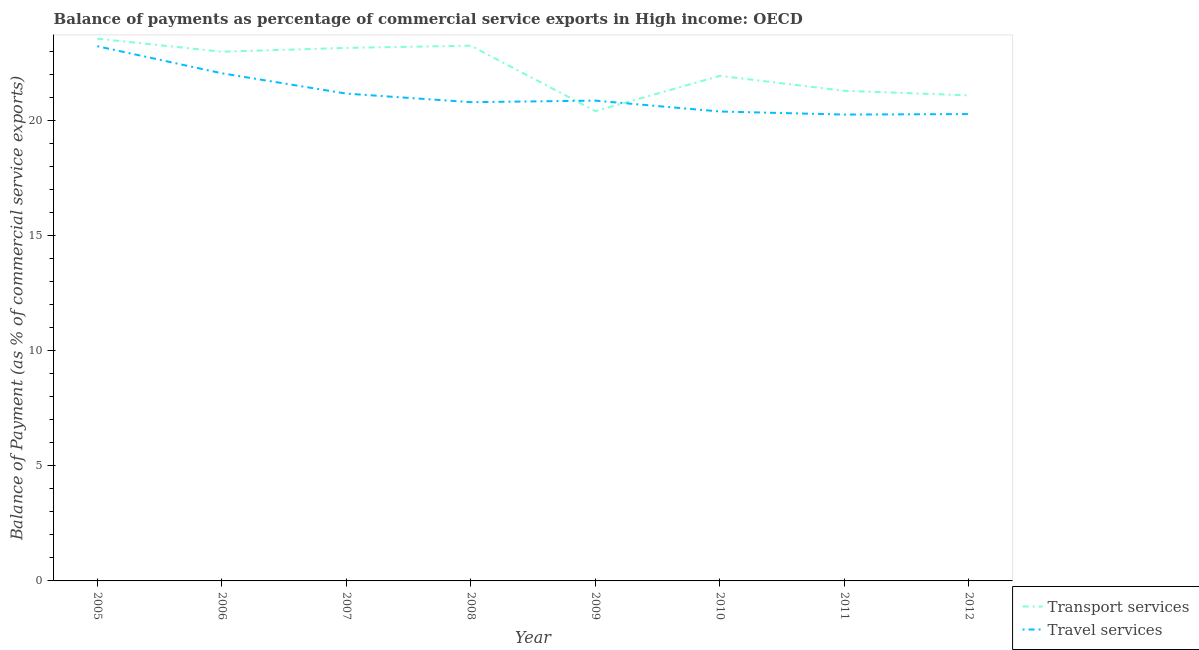How many different coloured lines are there?
Your answer should be very brief. 2. Does the line corresponding to balance of payments of travel services intersect with the line corresponding to balance of payments of transport services?
Give a very brief answer. Yes. What is the balance of payments of transport services in 2009?
Offer a very short reply. 20.43. Across all years, what is the maximum balance of payments of transport services?
Provide a succinct answer. 23.58. Across all years, what is the minimum balance of payments of transport services?
Offer a very short reply. 20.43. In which year was the balance of payments of transport services minimum?
Keep it short and to the point. 2009. What is the total balance of payments of travel services in the graph?
Your answer should be very brief. 169.21. What is the difference between the balance of payments of travel services in 2007 and that in 2012?
Keep it short and to the point. 0.89. What is the difference between the balance of payments of travel services in 2008 and the balance of payments of transport services in 2005?
Give a very brief answer. -2.76. What is the average balance of payments of transport services per year?
Your answer should be very brief. 22.23. In the year 2008, what is the difference between the balance of payments of transport services and balance of payments of travel services?
Offer a very short reply. 2.46. What is the ratio of the balance of payments of travel services in 2006 to that in 2011?
Offer a very short reply. 1.09. What is the difference between the highest and the second highest balance of payments of travel services?
Give a very brief answer. 1.18. What is the difference between the highest and the lowest balance of payments of transport services?
Make the answer very short. 3.15. Is the balance of payments of transport services strictly greater than the balance of payments of travel services over the years?
Your answer should be very brief. No. Is the balance of payments of travel services strictly less than the balance of payments of transport services over the years?
Your answer should be compact. No. How many lines are there?
Ensure brevity in your answer.  2. How many years are there in the graph?
Provide a short and direct response. 8. What is the difference between two consecutive major ticks on the Y-axis?
Ensure brevity in your answer.  5. Are the values on the major ticks of Y-axis written in scientific E-notation?
Give a very brief answer. No. Does the graph contain any zero values?
Offer a very short reply. No. Does the graph contain grids?
Your response must be concise. No. How many legend labels are there?
Provide a succinct answer. 2. How are the legend labels stacked?
Keep it short and to the point. Vertical. What is the title of the graph?
Your response must be concise. Balance of payments as percentage of commercial service exports in High income: OECD. Does "Passenger Transport Items" appear as one of the legend labels in the graph?
Provide a succinct answer. No. What is the label or title of the X-axis?
Make the answer very short. Year. What is the label or title of the Y-axis?
Keep it short and to the point. Balance of Payment (as % of commercial service exports). What is the Balance of Payment (as % of commercial service exports) of Transport services in 2005?
Provide a short and direct response. 23.58. What is the Balance of Payment (as % of commercial service exports) of Travel services in 2005?
Offer a terse response. 23.25. What is the Balance of Payment (as % of commercial service exports) in Transport services in 2006?
Your answer should be compact. 23.01. What is the Balance of Payment (as % of commercial service exports) of Travel services in 2006?
Offer a terse response. 22.07. What is the Balance of Payment (as % of commercial service exports) of Transport services in 2007?
Ensure brevity in your answer.  23.18. What is the Balance of Payment (as % of commercial service exports) in Travel services in 2007?
Make the answer very short. 21.19. What is the Balance of Payment (as % of commercial service exports) of Transport services in 2008?
Your response must be concise. 23.27. What is the Balance of Payment (as % of commercial service exports) in Travel services in 2008?
Keep it short and to the point. 20.82. What is the Balance of Payment (as % of commercial service exports) in Transport services in 2009?
Ensure brevity in your answer.  20.43. What is the Balance of Payment (as % of commercial service exports) of Travel services in 2009?
Provide a short and direct response. 20.88. What is the Balance of Payment (as % of commercial service exports) of Transport services in 2010?
Provide a succinct answer. 21.96. What is the Balance of Payment (as % of commercial service exports) of Travel services in 2010?
Offer a very short reply. 20.41. What is the Balance of Payment (as % of commercial service exports) in Transport services in 2011?
Give a very brief answer. 21.31. What is the Balance of Payment (as % of commercial service exports) of Travel services in 2011?
Offer a very short reply. 20.28. What is the Balance of Payment (as % of commercial service exports) in Transport services in 2012?
Offer a terse response. 21.11. What is the Balance of Payment (as % of commercial service exports) in Travel services in 2012?
Provide a short and direct response. 20.3. Across all years, what is the maximum Balance of Payment (as % of commercial service exports) in Transport services?
Your answer should be compact. 23.58. Across all years, what is the maximum Balance of Payment (as % of commercial service exports) in Travel services?
Offer a very short reply. 23.25. Across all years, what is the minimum Balance of Payment (as % of commercial service exports) in Transport services?
Offer a very short reply. 20.43. Across all years, what is the minimum Balance of Payment (as % of commercial service exports) in Travel services?
Provide a succinct answer. 20.28. What is the total Balance of Payment (as % of commercial service exports) of Transport services in the graph?
Make the answer very short. 177.86. What is the total Balance of Payment (as % of commercial service exports) of Travel services in the graph?
Provide a short and direct response. 169.21. What is the difference between the Balance of Payment (as % of commercial service exports) of Transport services in 2005 and that in 2006?
Offer a terse response. 0.57. What is the difference between the Balance of Payment (as % of commercial service exports) in Travel services in 2005 and that in 2006?
Make the answer very short. 1.18. What is the difference between the Balance of Payment (as % of commercial service exports) of Transport services in 2005 and that in 2007?
Your answer should be compact. 0.4. What is the difference between the Balance of Payment (as % of commercial service exports) in Travel services in 2005 and that in 2007?
Make the answer very short. 2.06. What is the difference between the Balance of Payment (as % of commercial service exports) of Transport services in 2005 and that in 2008?
Provide a succinct answer. 0.31. What is the difference between the Balance of Payment (as % of commercial service exports) of Travel services in 2005 and that in 2008?
Offer a terse response. 2.43. What is the difference between the Balance of Payment (as % of commercial service exports) of Transport services in 2005 and that in 2009?
Your answer should be compact. 3.15. What is the difference between the Balance of Payment (as % of commercial service exports) of Travel services in 2005 and that in 2009?
Offer a terse response. 2.37. What is the difference between the Balance of Payment (as % of commercial service exports) of Transport services in 2005 and that in 2010?
Your response must be concise. 1.62. What is the difference between the Balance of Payment (as % of commercial service exports) in Travel services in 2005 and that in 2010?
Provide a succinct answer. 2.84. What is the difference between the Balance of Payment (as % of commercial service exports) in Transport services in 2005 and that in 2011?
Your response must be concise. 2.27. What is the difference between the Balance of Payment (as % of commercial service exports) of Travel services in 2005 and that in 2011?
Make the answer very short. 2.97. What is the difference between the Balance of Payment (as % of commercial service exports) of Transport services in 2005 and that in 2012?
Your response must be concise. 2.47. What is the difference between the Balance of Payment (as % of commercial service exports) in Travel services in 2005 and that in 2012?
Your answer should be compact. 2.95. What is the difference between the Balance of Payment (as % of commercial service exports) of Transport services in 2006 and that in 2007?
Provide a succinct answer. -0.17. What is the difference between the Balance of Payment (as % of commercial service exports) of Travel services in 2006 and that in 2007?
Your answer should be very brief. 0.88. What is the difference between the Balance of Payment (as % of commercial service exports) in Transport services in 2006 and that in 2008?
Your answer should be very brief. -0.26. What is the difference between the Balance of Payment (as % of commercial service exports) in Travel services in 2006 and that in 2008?
Provide a succinct answer. 1.26. What is the difference between the Balance of Payment (as % of commercial service exports) in Transport services in 2006 and that in 2009?
Offer a very short reply. 2.58. What is the difference between the Balance of Payment (as % of commercial service exports) of Travel services in 2006 and that in 2009?
Make the answer very short. 1.19. What is the difference between the Balance of Payment (as % of commercial service exports) of Transport services in 2006 and that in 2010?
Provide a succinct answer. 1.05. What is the difference between the Balance of Payment (as % of commercial service exports) of Travel services in 2006 and that in 2010?
Make the answer very short. 1.66. What is the difference between the Balance of Payment (as % of commercial service exports) in Transport services in 2006 and that in 2011?
Your answer should be very brief. 1.7. What is the difference between the Balance of Payment (as % of commercial service exports) in Travel services in 2006 and that in 2011?
Ensure brevity in your answer.  1.8. What is the difference between the Balance of Payment (as % of commercial service exports) of Transport services in 2006 and that in 2012?
Ensure brevity in your answer.  1.9. What is the difference between the Balance of Payment (as % of commercial service exports) of Travel services in 2006 and that in 2012?
Keep it short and to the point. 1.77. What is the difference between the Balance of Payment (as % of commercial service exports) in Transport services in 2007 and that in 2008?
Keep it short and to the point. -0.1. What is the difference between the Balance of Payment (as % of commercial service exports) in Travel services in 2007 and that in 2008?
Make the answer very short. 0.37. What is the difference between the Balance of Payment (as % of commercial service exports) of Transport services in 2007 and that in 2009?
Make the answer very short. 2.75. What is the difference between the Balance of Payment (as % of commercial service exports) of Travel services in 2007 and that in 2009?
Your response must be concise. 0.31. What is the difference between the Balance of Payment (as % of commercial service exports) of Transport services in 2007 and that in 2010?
Provide a short and direct response. 1.22. What is the difference between the Balance of Payment (as % of commercial service exports) of Travel services in 2007 and that in 2010?
Offer a very short reply. 0.78. What is the difference between the Balance of Payment (as % of commercial service exports) of Transport services in 2007 and that in 2011?
Your response must be concise. 1.86. What is the difference between the Balance of Payment (as % of commercial service exports) in Travel services in 2007 and that in 2011?
Offer a terse response. 0.91. What is the difference between the Balance of Payment (as % of commercial service exports) in Transport services in 2007 and that in 2012?
Give a very brief answer. 2.06. What is the difference between the Balance of Payment (as % of commercial service exports) in Travel services in 2007 and that in 2012?
Make the answer very short. 0.89. What is the difference between the Balance of Payment (as % of commercial service exports) in Transport services in 2008 and that in 2009?
Offer a very short reply. 2.84. What is the difference between the Balance of Payment (as % of commercial service exports) in Travel services in 2008 and that in 2009?
Provide a short and direct response. -0.07. What is the difference between the Balance of Payment (as % of commercial service exports) of Transport services in 2008 and that in 2010?
Make the answer very short. 1.31. What is the difference between the Balance of Payment (as % of commercial service exports) in Travel services in 2008 and that in 2010?
Give a very brief answer. 0.41. What is the difference between the Balance of Payment (as % of commercial service exports) in Transport services in 2008 and that in 2011?
Make the answer very short. 1.96. What is the difference between the Balance of Payment (as % of commercial service exports) of Travel services in 2008 and that in 2011?
Ensure brevity in your answer.  0.54. What is the difference between the Balance of Payment (as % of commercial service exports) of Transport services in 2008 and that in 2012?
Your response must be concise. 2.16. What is the difference between the Balance of Payment (as % of commercial service exports) in Travel services in 2008 and that in 2012?
Keep it short and to the point. 0.52. What is the difference between the Balance of Payment (as % of commercial service exports) in Transport services in 2009 and that in 2010?
Offer a terse response. -1.53. What is the difference between the Balance of Payment (as % of commercial service exports) in Travel services in 2009 and that in 2010?
Your response must be concise. 0.47. What is the difference between the Balance of Payment (as % of commercial service exports) of Transport services in 2009 and that in 2011?
Ensure brevity in your answer.  -0.88. What is the difference between the Balance of Payment (as % of commercial service exports) in Travel services in 2009 and that in 2011?
Provide a short and direct response. 0.61. What is the difference between the Balance of Payment (as % of commercial service exports) of Transport services in 2009 and that in 2012?
Provide a short and direct response. -0.68. What is the difference between the Balance of Payment (as % of commercial service exports) of Travel services in 2009 and that in 2012?
Your answer should be very brief. 0.58. What is the difference between the Balance of Payment (as % of commercial service exports) in Transport services in 2010 and that in 2011?
Give a very brief answer. 0.65. What is the difference between the Balance of Payment (as % of commercial service exports) of Travel services in 2010 and that in 2011?
Give a very brief answer. 0.13. What is the difference between the Balance of Payment (as % of commercial service exports) in Transport services in 2010 and that in 2012?
Offer a very short reply. 0.85. What is the difference between the Balance of Payment (as % of commercial service exports) in Travel services in 2010 and that in 2012?
Your response must be concise. 0.11. What is the difference between the Balance of Payment (as % of commercial service exports) in Transport services in 2011 and that in 2012?
Ensure brevity in your answer.  0.2. What is the difference between the Balance of Payment (as % of commercial service exports) in Travel services in 2011 and that in 2012?
Your answer should be very brief. -0.02. What is the difference between the Balance of Payment (as % of commercial service exports) in Transport services in 2005 and the Balance of Payment (as % of commercial service exports) in Travel services in 2006?
Your answer should be very brief. 1.51. What is the difference between the Balance of Payment (as % of commercial service exports) of Transport services in 2005 and the Balance of Payment (as % of commercial service exports) of Travel services in 2007?
Provide a short and direct response. 2.39. What is the difference between the Balance of Payment (as % of commercial service exports) of Transport services in 2005 and the Balance of Payment (as % of commercial service exports) of Travel services in 2008?
Your answer should be very brief. 2.76. What is the difference between the Balance of Payment (as % of commercial service exports) in Transport services in 2005 and the Balance of Payment (as % of commercial service exports) in Travel services in 2009?
Make the answer very short. 2.69. What is the difference between the Balance of Payment (as % of commercial service exports) of Transport services in 2005 and the Balance of Payment (as % of commercial service exports) of Travel services in 2010?
Keep it short and to the point. 3.17. What is the difference between the Balance of Payment (as % of commercial service exports) in Transport services in 2005 and the Balance of Payment (as % of commercial service exports) in Travel services in 2011?
Offer a terse response. 3.3. What is the difference between the Balance of Payment (as % of commercial service exports) of Transport services in 2005 and the Balance of Payment (as % of commercial service exports) of Travel services in 2012?
Offer a terse response. 3.28. What is the difference between the Balance of Payment (as % of commercial service exports) in Transport services in 2006 and the Balance of Payment (as % of commercial service exports) in Travel services in 2007?
Provide a short and direct response. 1.82. What is the difference between the Balance of Payment (as % of commercial service exports) in Transport services in 2006 and the Balance of Payment (as % of commercial service exports) in Travel services in 2008?
Offer a very short reply. 2.19. What is the difference between the Balance of Payment (as % of commercial service exports) in Transport services in 2006 and the Balance of Payment (as % of commercial service exports) in Travel services in 2009?
Offer a terse response. 2.13. What is the difference between the Balance of Payment (as % of commercial service exports) in Transport services in 2006 and the Balance of Payment (as % of commercial service exports) in Travel services in 2010?
Keep it short and to the point. 2.6. What is the difference between the Balance of Payment (as % of commercial service exports) in Transport services in 2006 and the Balance of Payment (as % of commercial service exports) in Travel services in 2011?
Give a very brief answer. 2.73. What is the difference between the Balance of Payment (as % of commercial service exports) in Transport services in 2006 and the Balance of Payment (as % of commercial service exports) in Travel services in 2012?
Keep it short and to the point. 2.71. What is the difference between the Balance of Payment (as % of commercial service exports) in Transport services in 2007 and the Balance of Payment (as % of commercial service exports) in Travel services in 2008?
Give a very brief answer. 2.36. What is the difference between the Balance of Payment (as % of commercial service exports) in Transport services in 2007 and the Balance of Payment (as % of commercial service exports) in Travel services in 2009?
Your answer should be very brief. 2.29. What is the difference between the Balance of Payment (as % of commercial service exports) in Transport services in 2007 and the Balance of Payment (as % of commercial service exports) in Travel services in 2010?
Your answer should be very brief. 2.77. What is the difference between the Balance of Payment (as % of commercial service exports) in Transport services in 2007 and the Balance of Payment (as % of commercial service exports) in Travel services in 2011?
Ensure brevity in your answer.  2.9. What is the difference between the Balance of Payment (as % of commercial service exports) in Transport services in 2007 and the Balance of Payment (as % of commercial service exports) in Travel services in 2012?
Your response must be concise. 2.88. What is the difference between the Balance of Payment (as % of commercial service exports) of Transport services in 2008 and the Balance of Payment (as % of commercial service exports) of Travel services in 2009?
Your answer should be compact. 2.39. What is the difference between the Balance of Payment (as % of commercial service exports) of Transport services in 2008 and the Balance of Payment (as % of commercial service exports) of Travel services in 2010?
Offer a very short reply. 2.86. What is the difference between the Balance of Payment (as % of commercial service exports) of Transport services in 2008 and the Balance of Payment (as % of commercial service exports) of Travel services in 2011?
Your response must be concise. 3. What is the difference between the Balance of Payment (as % of commercial service exports) in Transport services in 2008 and the Balance of Payment (as % of commercial service exports) in Travel services in 2012?
Your answer should be very brief. 2.97. What is the difference between the Balance of Payment (as % of commercial service exports) in Transport services in 2009 and the Balance of Payment (as % of commercial service exports) in Travel services in 2010?
Give a very brief answer. 0.02. What is the difference between the Balance of Payment (as % of commercial service exports) of Transport services in 2009 and the Balance of Payment (as % of commercial service exports) of Travel services in 2011?
Provide a succinct answer. 0.15. What is the difference between the Balance of Payment (as % of commercial service exports) in Transport services in 2009 and the Balance of Payment (as % of commercial service exports) in Travel services in 2012?
Your answer should be very brief. 0.13. What is the difference between the Balance of Payment (as % of commercial service exports) in Transport services in 2010 and the Balance of Payment (as % of commercial service exports) in Travel services in 2011?
Ensure brevity in your answer.  1.68. What is the difference between the Balance of Payment (as % of commercial service exports) in Transport services in 2010 and the Balance of Payment (as % of commercial service exports) in Travel services in 2012?
Provide a short and direct response. 1.66. What is the difference between the Balance of Payment (as % of commercial service exports) in Transport services in 2011 and the Balance of Payment (as % of commercial service exports) in Travel services in 2012?
Make the answer very short. 1.01. What is the average Balance of Payment (as % of commercial service exports) in Transport services per year?
Offer a very short reply. 22.23. What is the average Balance of Payment (as % of commercial service exports) in Travel services per year?
Your response must be concise. 21.15. In the year 2005, what is the difference between the Balance of Payment (as % of commercial service exports) of Transport services and Balance of Payment (as % of commercial service exports) of Travel services?
Make the answer very short. 0.33. In the year 2006, what is the difference between the Balance of Payment (as % of commercial service exports) in Transport services and Balance of Payment (as % of commercial service exports) in Travel services?
Your answer should be compact. 0.94. In the year 2007, what is the difference between the Balance of Payment (as % of commercial service exports) in Transport services and Balance of Payment (as % of commercial service exports) in Travel services?
Give a very brief answer. 1.99. In the year 2008, what is the difference between the Balance of Payment (as % of commercial service exports) in Transport services and Balance of Payment (as % of commercial service exports) in Travel services?
Provide a short and direct response. 2.46. In the year 2009, what is the difference between the Balance of Payment (as % of commercial service exports) of Transport services and Balance of Payment (as % of commercial service exports) of Travel services?
Give a very brief answer. -0.45. In the year 2010, what is the difference between the Balance of Payment (as % of commercial service exports) of Transport services and Balance of Payment (as % of commercial service exports) of Travel services?
Offer a terse response. 1.55. In the year 2011, what is the difference between the Balance of Payment (as % of commercial service exports) in Transport services and Balance of Payment (as % of commercial service exports) in Travel services?
Provide a short and direct response. 1.03. In the year 2012, what is the difference between the Balance of Payment (as % of commercial service exports) in Transport services and Balance of Payment (as % of commercial service exports) in Travel services?
Your response must be concise. 0.81. What is the ratio of the Balance of Payment (as % of commercial service exports) of Transport services in 2005 to that in 2006?
Ensure brevity in your answer.  1.02. What is the ratio of the Balance of Payment (as % of commercial service exports) of Travel services in 2005 to that in 2006?
Your answer should be compact. 1.05. What is the ratio of the Balance of Payment (as % of commercial service exports) of Transport services in 2005 to that in 2007?
Offer a very short reply. 1.02. What is the ratio of the Balance of Payment (as % of commercial service exports) in Travel services in 2005 to that in 2007?
Offer a very short reply. 1.1. What is the ratio of the Balance of Payment (as % of commercial service exports) in Transport services in 2005 to that in 2008?
Make the answer very short. 1.01. What is the ratio of the Balance of Payment (as % of commercial service exports) in Travel services in 2005 to that in 2008?
Offer a terse response. 1.12. What is the ratio of the Balance of Payment (as % of commercial service exports) of Transport services in 2005 to that in 2009?
Provide a succinct answer. 1.15. What is the ratio of the Balance of Payment (as % of commercial service exports) in Travel services in 2005 to that in 2009?
Keep it short and to the point. 1.11. What is the ratio of the Balance of Payment (as % of commercial service exports) of Transport services in 2005 to that in 2010?
Provide a succinct answer. 1.07. What is the ratio of the Balance of Payment (as % of commercial service exports) of Travel services in 2005 to that in 2010?
Keep it short and to the point. 1.14. What is the ratio of the Balance of Payment (as % of commercial service exports) of Transport services in 2005 to that in 2011?
Keep it short and to the point. 1.11. What is the ratio of the Balance of Payment (as % of commercial service exports) of Travel services in 2005 to that in 2011?
Keep it short and to the point. 1.15. What is the ratio of the Balance of Payment (as % of commercial service exports) in Transport services in 2005 to that in 2012?
Your answer should be very brief. 1.12. What is the ratio of the Balance of Payment (as % of commercial service exports) in Travel services in 2005 to that in 2012?
Your answer should be very brief. 1.15. What is the ratio of the Balance of Payment (as % of commercial service exports) of Transport services in 2006 to that in 2007?
Provide a succinct answer. 0.99. What is the ratio of the Balance of Payment (as % of commercial service exports) in Travel services in 2006 to that in 2007?
Ensure brevity in your answer.  1.04. What is the ratio of the Balance of Payment (as % of commercial service exports) of Travel services in 2006 to that in 2008?
Offer a terse response. 1.06. What is the ratio of the Balance of Payment (as % of commercial service exports) of Transport services in 2006 to that in 2009?
Your answer should be very brief. 1.13. What is the ratio of the Balance of Payment (as % of commercial service exports) of Travel services in 2006 to that in 2009?
Provide a succinct answer. 1.06. What is the ratio of the Balance of Payment (as % of commercial service exports) in Transport services in 2006 to that in 2010?
Make the answer very short. 1.05. What is the ratio of the Balance of Payment (as % of commercial service exports) of Travel services in 2006 to that in 2010?
Your response must be concise. 1.08. What is the ratio of the Balance of Payment (as % of commercial service exports) of Transport services in 2006 to that in 2011?
Your answer should be very brief. 1.08. What is the ratio of the Balance of Payment (as % of commercial service exports) in Travel services in 2006 to that in 2011?
Your answer should be very brief. 1.09. What is the ratio of the Balance of Payment (as % of commercial service exports) in Transport services in 2006 to that in 2012?
Ensure brevity in your answer.  1.09. What is the ratio of the Balance of Payment (as % of commercial service exports) in Travel services in 2006 to that in 2012?
Provide a short and direct response. 1.09. What is the ratio of the Balance of Payment (as % of commercial service exports) of Transport services in 2007 to that in 2008?
Ensure brevity in your answer.  1. What is the ratio of the Balance of Payment (as % of commercial service exports) in Travel services in 2007 to that in 2008?
Your response must be concise. 1.02. What is the ratio of the Balance of Payment (as % of commercial service exports) in Transport services in 2007 to that in 2009?
Keep it short and to the point. 1.13. What is the ratio of the Balance of Payment (as % of commercial service exports) in Travel services in 2007 to that in 2009?
Keep it short and to the point. 1.01. What is the ratio of the Balance of Payment (as % of commercial service exports) in Transport services in 2007 to that in 2010?
Your response must be concise. 1.06. What is the ratio of the Balance of Payment (as % of commercial service exports) in Travel services in 2007 to that in 2010?
Your answer should be compact. 1.04. What is the ratio of the Balance of Payment (as % of commercial service exports) in Transport services in 2007 to that in 2011?
Make the answer very short. 1.09. What is the ratio of the Balance of Payment (as % of commercial service exports) of Travel services in 2007 to that in 2011?
Your answer should be very brief. 1.04. What is the ratio of the Balance of Payment (as % of commercial service exports) in Transport services in 2007 to that in 2012?
Provide a succinct answer. 1.1. What is the ratio of the Balance of Payment (as % of commercial service exports) in Travel services in 2007 to that in 2012?
Keep it short and to the point. 1.04. What is the ratio of the Balance of Payment (as % of commercial service exports) of Transport services in 2008 to that in 2009?
Provide a short and direct response. 1.14. What is the ratio of the Balance of Payment (as % of commercial service exports) of Transport services in 2008 to that in 2010?
Your answer should be compact. 1.06. What is the ratio of the Balance of Payment (as % of commercial service exports) of Travel services in 2008 to that in 2010?
Your answer should be compact. 1.02. What is the ratio of the Balance of Payment (as % of commercial service exports) in Transport services in 2008 to that in 2011?
Give a very brief answer. 1.09. What is the ratio of the Balance of Payment (as % of commercial service exports) in Travel services in 2008 to that in 2011?
Provide a succinct answer. 1.03. What is the ratio of the Balance of Payment (as % of commercial service exports) of Transport services in 2008 to that in 2012?
Offer a very short reply. 1.1. What is the ratio of the Balance of Payment (as % of commercial service exports) of Travel services in 2008 to that in 2012?
Provide a short and direct response. 1.03. What is the ratio of the Balance of Payment (as % of commercial service exports) of Transport services in 2009 to that in 2010?
Offer a very short reply. 0.93. What is the ratio of the Balance of Payment (as % of commercial service exports) in Travel services in 2009 to that in 2010?
Ensure brevity in your answer.  1.02. What is the ratio of the Balance of Payment (as % of commercial service exports) of Transport services in 2009 to that in 2011?
Give a very brief answer. 0.96. What is the ratio of the Balance of Payment (as % of commercial service exports) of Travel services in 2009 to that in 2011?
Offer a very short reply. 1.03. What is the ratio of the Balance of Payment (as % of commercial service exports) of Transport services in 2009 to that in 2012?
Provide a succinct answer. 0.97. What is the ratio of the Balance of Payment (as % of commercial service exports) in Travel services in 2009 to that in 2012?
Your answer should be very brief. 1.03. What is the ratio of the Balance of Payment (as % of commercial service exports) of Transport services in 2010 to that in 2011?
Keep it short and to the point. 1.03. What is the ratio of the Balance of Payment (as % of commercial service exports) in Travel services in 2010 to that in 2011?
Provide a short and direct response. 1.01. What is the ratio of the Balance of Payment (as % of commercial service exports) of Transport services in 2010 to that in 2012?
Your response must be concise. 1.04. What is the ratio of the Balance of Payment (as % of commercial service exports) of Travel services in 2010 to that in 2012?
Provide a succinct answer. 1.01. What is the ratio of the Balance of Payment (as % of commercial service exports) of Transport services in 2011 to that in 2012?
Your response must be concise. 1.01. What is the ratio of the Balance of Payment (as % of commercial service exports) in Travel services in 2011 to that in 2012?
Ensure brevity in your answer.  1. What is the difference between the highest and the second highest Balance of Payment (as % of commercial service exports) of Transport services?
Ensure brevity in your answer.  0.31. What is the difference between the highest and the second highest Balance of Payment (as % of commercial service exports) in Travel services?
Your answer should be very brief. 1.18. What is the difference between the highest and the lowest Balance of Payment (as % of commercial service exports) in Transport services?
Provide a short and direct response. 3.15. What is the difference between the highest and the lowest Balance of Payment (as % of commercial service exports) in Travel services?
Keep it short and to the point. 2.97. 